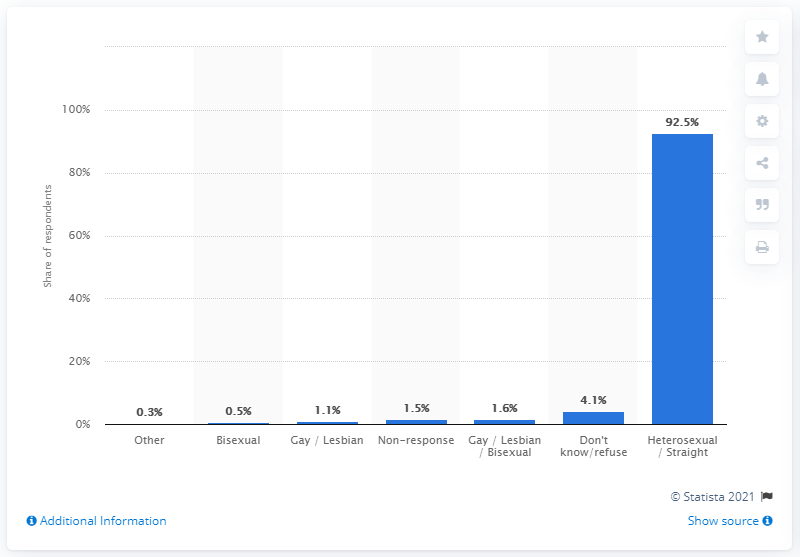Identify some key points in this picture. The response of respondents to the self-reported sexual identity survey in England in 2014 is reported as 4.1. According to the survey, 92.5% of respondents identified as heterosexual. 